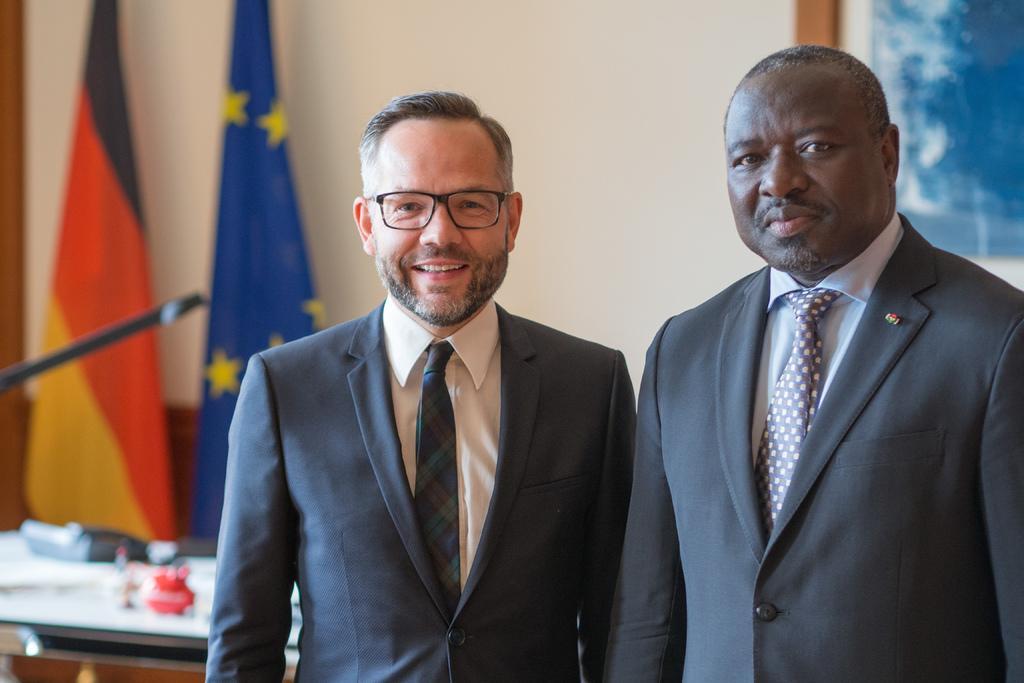Please provide a concise description of this image. In the image I can see people are standing and smiling. In the background, I can see some other objects. 